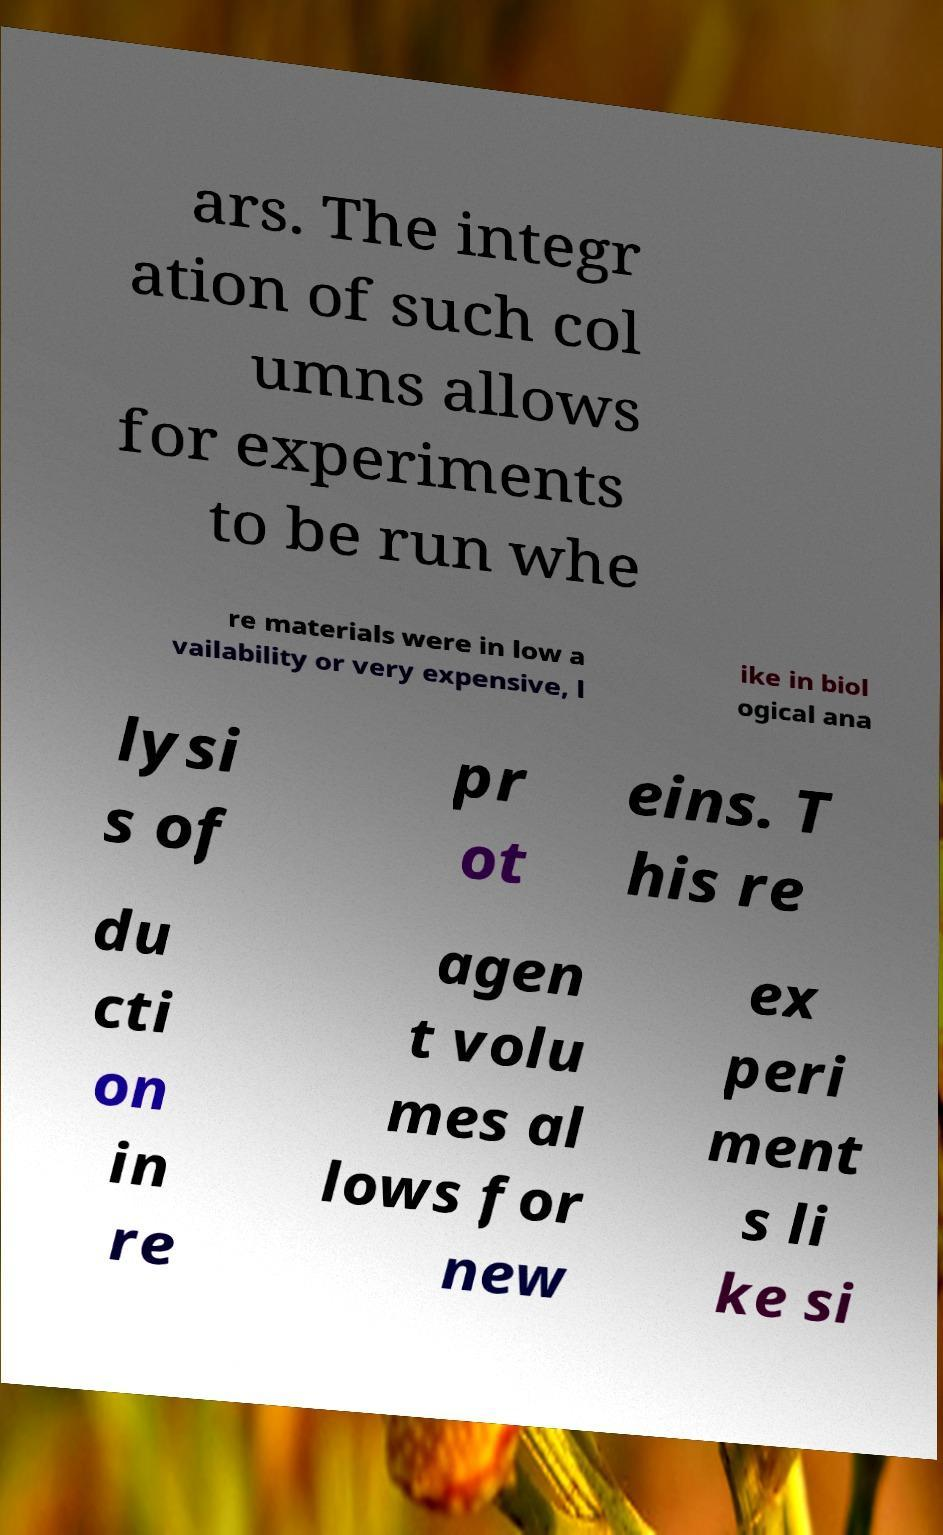Could you assist in decoding the text presented in this image and type it out clearly? ars. The integr ation of such col umns allows for experiments to be run whe re materials were in low a vailability or very expensive, l ike in biol ogical ana lysi s of pr ot eins. T his re du cti on in re agen t volu mes al lows for new ex peri ment s li ke si 